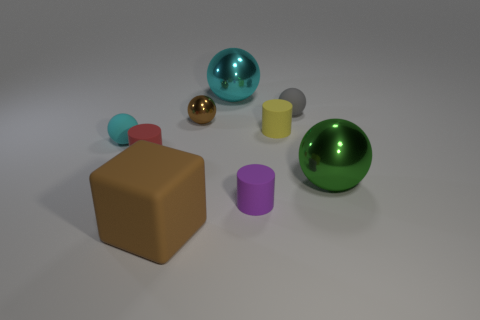Is the color of the big thing on the left side of the brown metallic ball the same as the small shiny thing? yes 